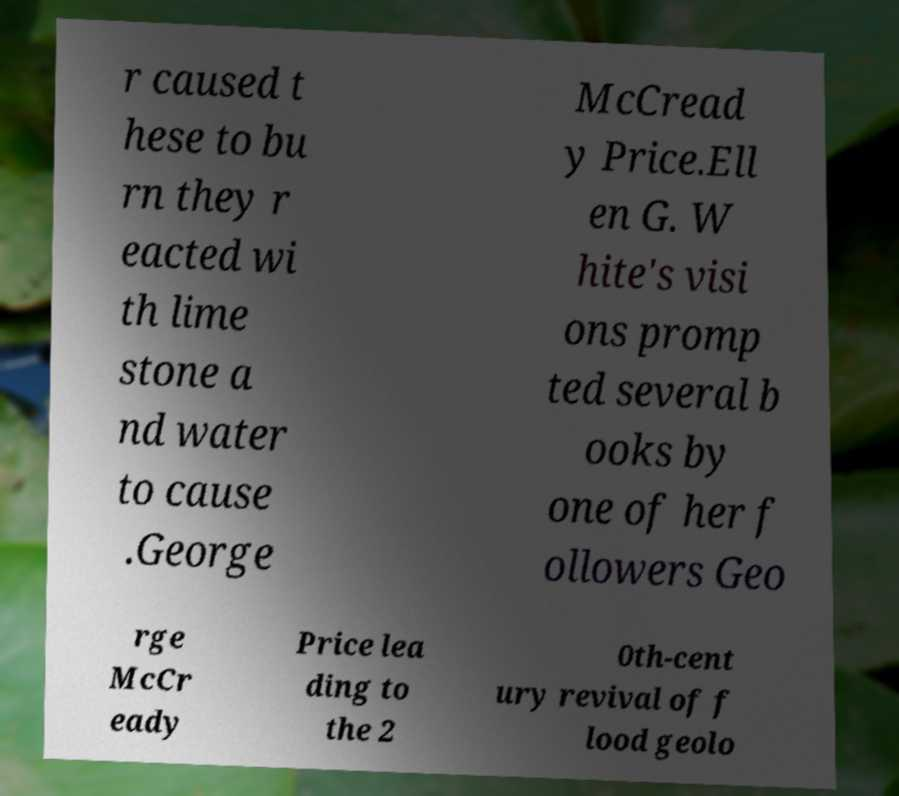There's text embedded in this image that I need extracted. Can you transcribe it verbatim? r caused t hese to bu rn they r eacted wi th lime stone a nd water to cause .George McCread y Price.Ell en G. W hite's visi ons promp ted several b ooks by one of her f ollowers Geo rge McCr eady Price lea ding to the 2 0th-cent ury revival of f lood geolo 